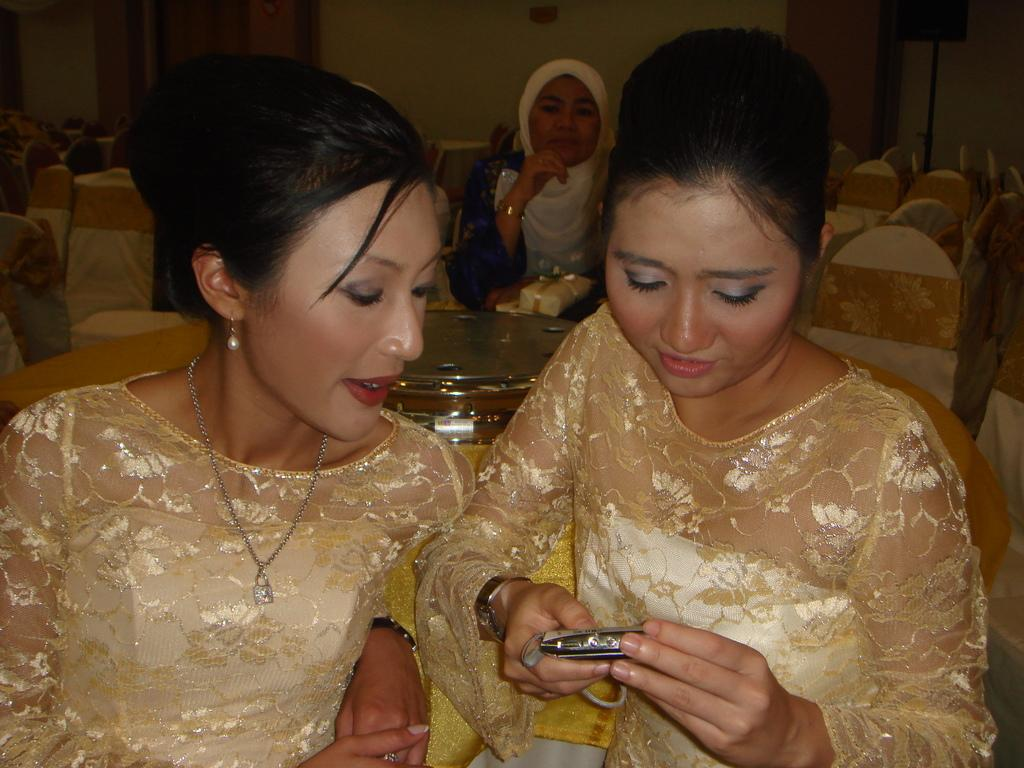What are the people in the image doing? The people in the image are sitting on chairs. Can you describe what one person is holding? One person is holding an object. What can be seen in the background of the image? There is a wall visible in the background of the image. What type of lunch is being served in the image? There is no lunch present in the image. What is the angle of the slope in the image? There is no slope present in the image. 